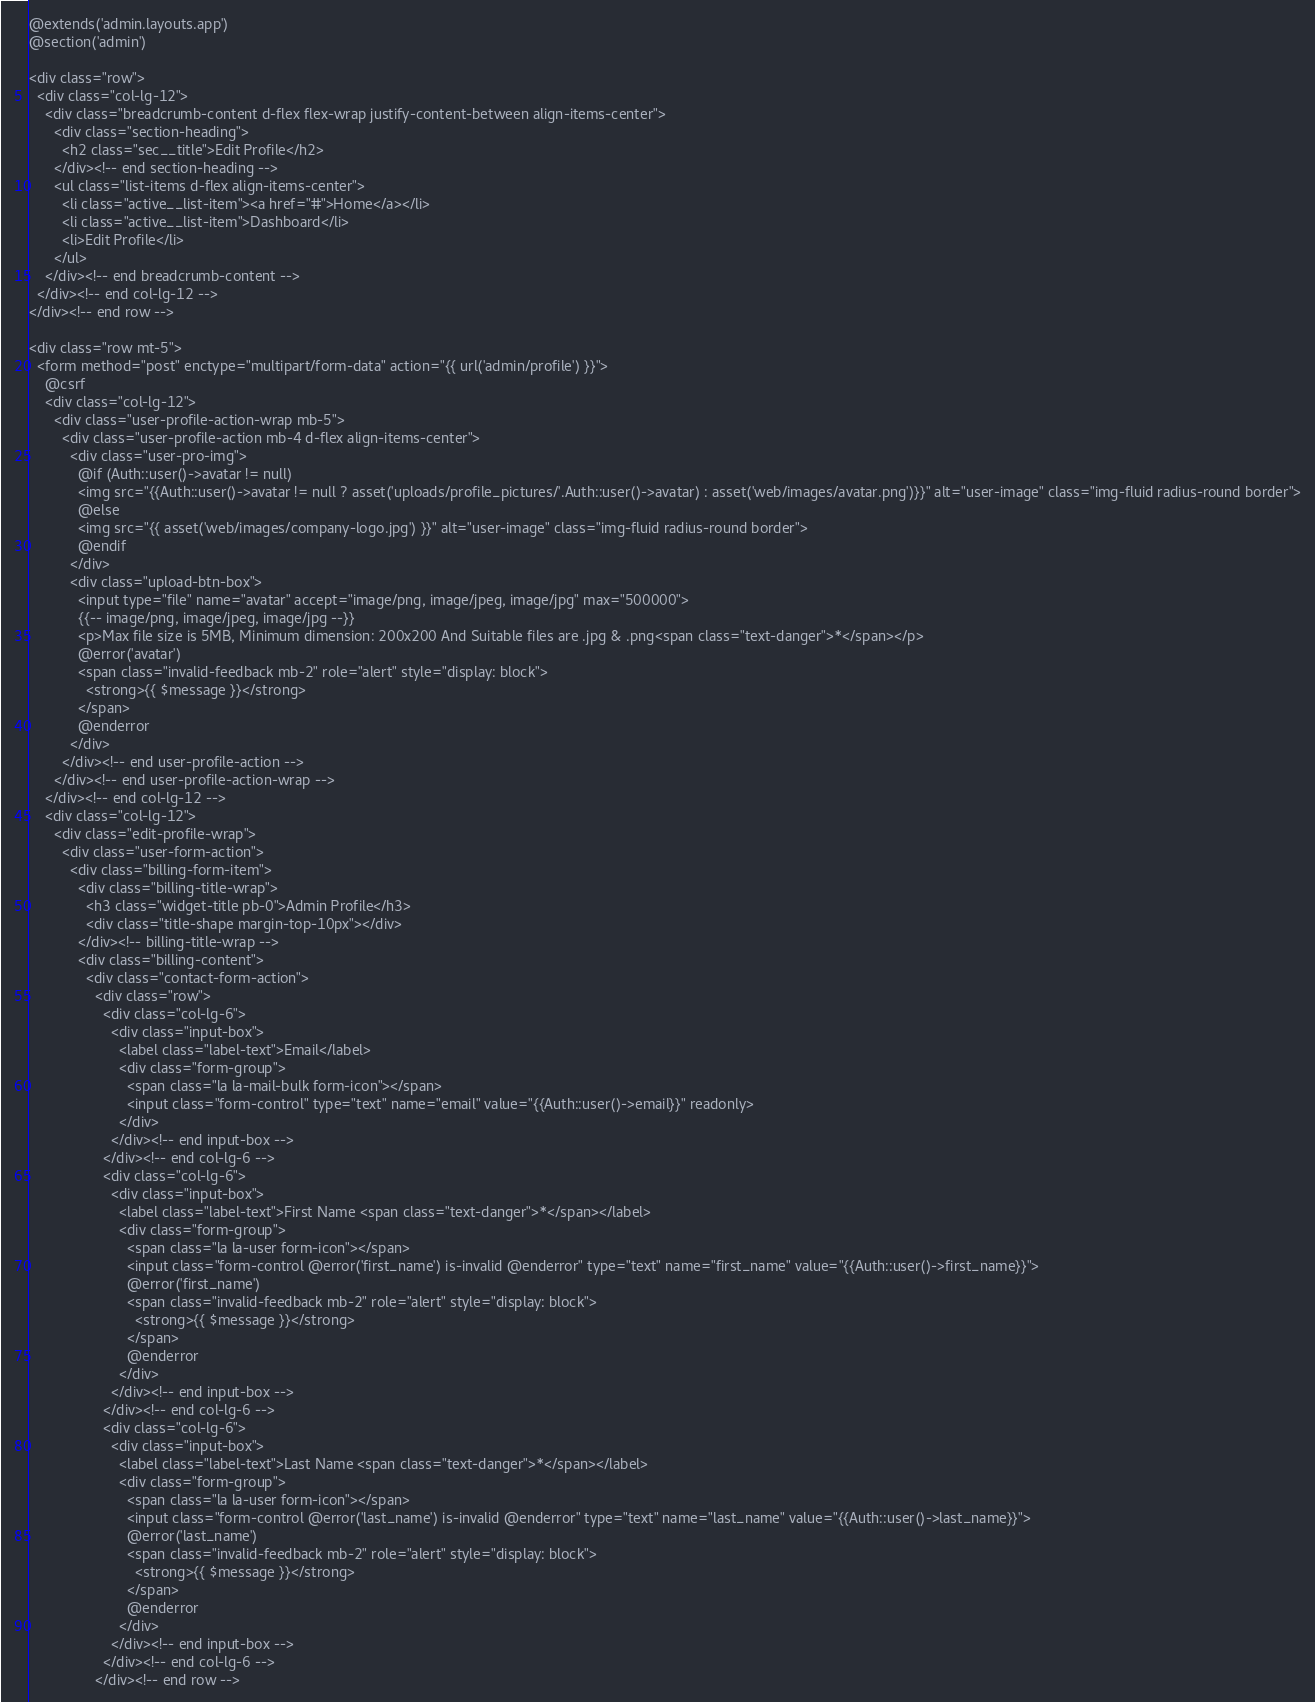Convert code to text. <code><loc_0><loc_0><loc_500><loc_500><_PHP_>@extends('admin.layouts.app')
@section('admin')

<div class="row">
  <div class="col-lg-12">
    <div class="breadcrumb-content d-flex flex-wrap justify-content-between align-items-center">
      <div class="section-heading">
        <h2 class="sec__title">Edit Profile</h2>
      </div><!-- end section-heading -->
      <ul class="list-items d-flex align-items-center">
        <li class="active__list-item"><a href="#">Home</a></li>
        <li class="active__list-item">Dashboard</li>
        <li>Edit Profile</li>
      </ul>
    </div><!-- end breadcrumb-content -->
  </div><!-- end col-lg-12 -->
</div><!-- end row -->

<div class="row mt-5">
  <form method="post" enctype="multipart/form-data" action="{{ url('admin/profile') }}">
    @csrf
    <div class="col-lg-12">
      <div class="user-profile-action-wrap mb-5">
        <div class="user-profile-action mb-4 d-flex align-items-center">
          <div class="user-pro-img">
            @if (Auth::user()->avatar != null)
            <img src="{{Auth::user()->avatar != null ? asset('uploads/profile_pictures/'.Auth::user()->avatar) : asset('web/images/avatar.png')}}" alt="user-image" class="img-fluid radius-round border">
            @else
            <img src="{{ asset('web/images/company-logo.jpg') }}" alt="user-image" class="img-fluid radius-round border">
            @endif
          </div>
          <div class="upload-btn-box">
            <input type="file" name="avatar" accept="image/png, image/jpeg, image/jpg" max="500000">
            {{-- image/png, image/jpeg, image/jpg --}}
            <p>Max file size is 5MB, Minimum dimension: 200x200 And Suitable files are .jpg & .png<span class="text-danger">*</span></p>
            @error('avatar')
            <span class="invalid-feedback mb-2" role="alert" style="display: block">
              <strong>{{ $message }}</strong>
            </span>
            @enderror
          </div>
        </div><!-- end user-profile-action -->
      </div><!-- end user-profile-action-wrap -->
    </div><!-- end col-lg-12 -->
    <div class="col-lg-12">
      <div class="edit-profile-wrap">
        <div class="user-form-action">
          <div class="billing-form-item">
            <div class="billing-title-wrap">
              <h3 class="widget-title pb-0">Admin Profile</h3>
              <div class="title-shape margin-top-10px"></div>
            </div><!-- billing-title-wrap -->
            <div class="billing-content">
              <div class="contact-form-action">
                <div class="row">
                  <div class="col-lg-6">
                    <div class="input-box">
                      <label class="label-text">Email</label>
                      <div class="form-group">
                        <span class="la la-mail-bulk form-icon"></span>
                        <input class="form-control" type="text" name="email" value="{{Auth::user()->email}}" readonly>
                      </div>
                    </div><!-- end input-box -->
                  </div><!-- end col-lg-6 -->
                  <div class="col-lg-6">
                    <div class="input-box">
                      <label class="label-text">First Name <span class="text-danger">*</span></label>
                      <div class="form-group">
                        <span class="la la-user form-icon"></span>
                        <input class="form-control @error('first_name') is-invalid @enderror" type="text" name="first_name" value="{{Auth::user()->first_name}}">
                        @error('first_name')
                        <span class="invalid-feedback mb-2" role="alert" style="display: block">
                          <strong>{{ $message }}</strong>
                        </span>
                        @enderror
                      </div>
                    </div><!-- end input-box -->
                  </div><!-- end col-lg-6 -->
                  <div class="col-lg-6">
                    <div class="input-box">
                      <label class="label-text">Last Name <span class="text-danger">*</span></label>
                      <div class="form-group">
                        <span class="la la-user form-icon"></span>
                        <input class="form-control @error('last_name') is-invalid @enderror" type="text" name="last_name" value="{{Auth::user()->last_name}}">
                        @error('last_name')
                        <span class="invalid-feedback mb-2" role="alert" style="display: block">
                          <strong>{{ $message }}</strong>
                        </span>
                        @enderror
                      </div>
                    </div><!-- end input-box -->
                  </div><!-- end col-lg-6 -->
                </div><!-- end row --></code> 